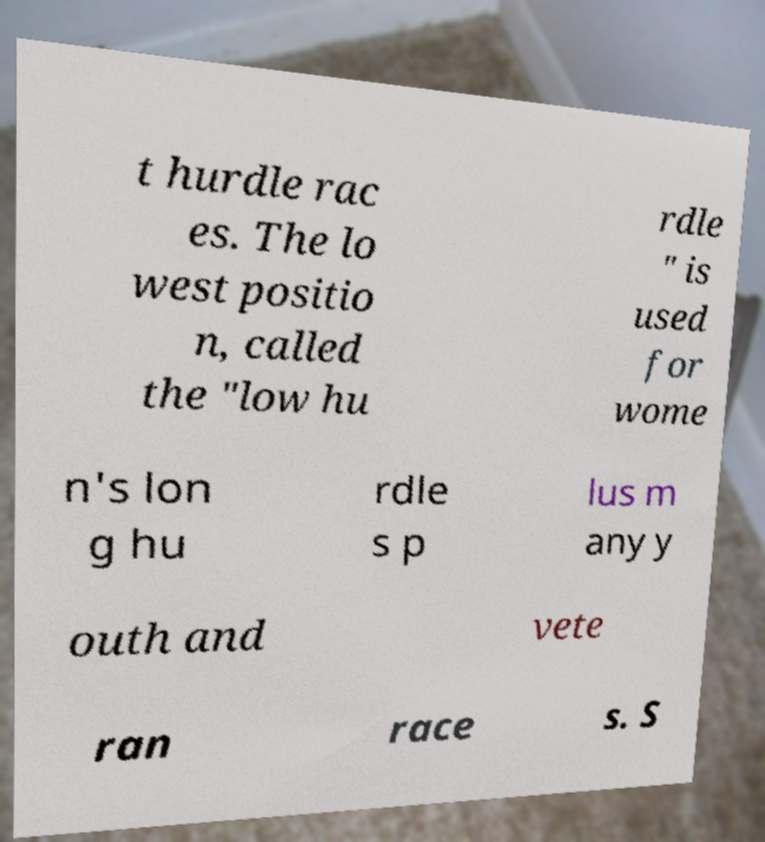What messages or text are displayed in this image? I need them in a readable, typed format. t hurdle rac es. The lo west positio n, called the "low hu rdle " is used for wome n's lon g hu rdle s p lus m any y outh and vete ran race s. S 